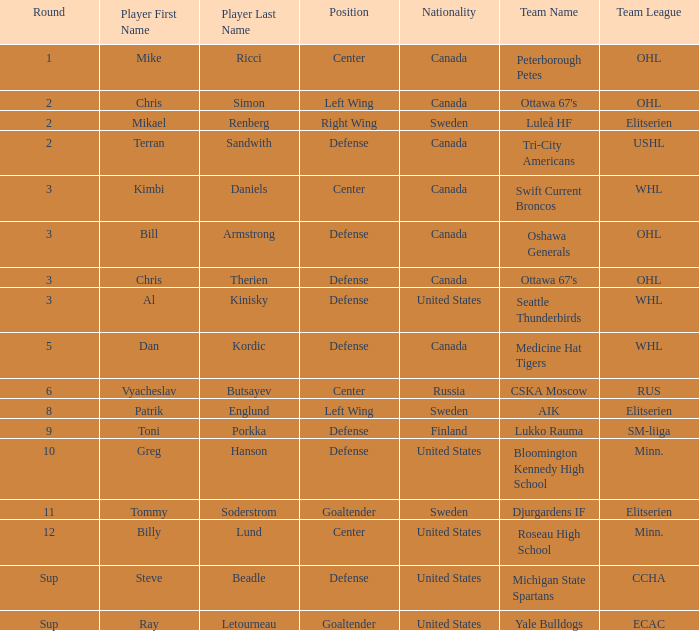Can you parse all the data within this table? {'header': ['Round', 'Player First Name', 'Player Last Name', 'Position', 'Nationality', 'Team Name', 'Team League'], 'rows': [['1', 'Mike', 'Ricci', 'Center', 'Canada', 'Peterborough Petes', 'OHL'], ['2', 'Chris', 'Simon', 'Left Wing', 'Canada', "Ottawa 67's", 'OHL'], ['2', 'Mikael', 'Renberg', 'Right Wing', 'Sweden', 'Luleå HF', 'Elitserien'], ['2', 'Terran', 'Sandwith', 'Defense', 'Canada', 'Tri-City Americans', 'USHL'], ['3', 'Kimbi', 'Daniels', 'Center', 'Canada', 'Swift Current Broncos', 'WHL'], ['3', 'Bill', 'Armstrong', 'Defense', 'Canada', 'Oshawa Generals', 'OHL'], ['3', 'Chris', 'Therien', 'Defense', 'Canada', "Ottawa 67's", 'OHL'], ['3', 'Al', 'Kinisky', 'Defense', 'United States', 'Seattle Thunderbirds', 'WHL'], ['5', 'Dan', 'Kordic', 'Defense', 'Canada', 'Medicine Hat Tigers', 'WHL'], ['6', 'Vyacheslav', 'Butsayev', 'Center', 'Russia', 'CSKA Moscow', 'RUS'], ['8', 'Patrik', 'Englund', 'Left Wing', 'Sweden', 'AIK', 'Elitserien'], ['9', 'Toni', 'Porkka', 'Defense', 'Finland', 'Lukko Rauma', 'SM-liiga'], ['10', 'Greg', 'Hanson', 'Defense', 'United States', 'Bloomington Kennedy High School', 'Minn.'], ['11', 'Tommy', 'Soderstrom', 'Goaltender', 'Sweden', 'Djurgardens IF', 'Elitserien'], ['12', 'Billy', 'Lund', 'Center', 'United States', 'Roseau High School', 'Minn.'], ['Sup', 'Steve', 'Beadle', 'Defense', 'United States', 'Michigan State Spartans', 'CCHA'], ['Sup', 'Ray', 'Letourneau', 'Goaltender', 'United States', 'Yale Bulldogs', 'ECAC']]} What player is playing on round 1 Mike Ricci. 